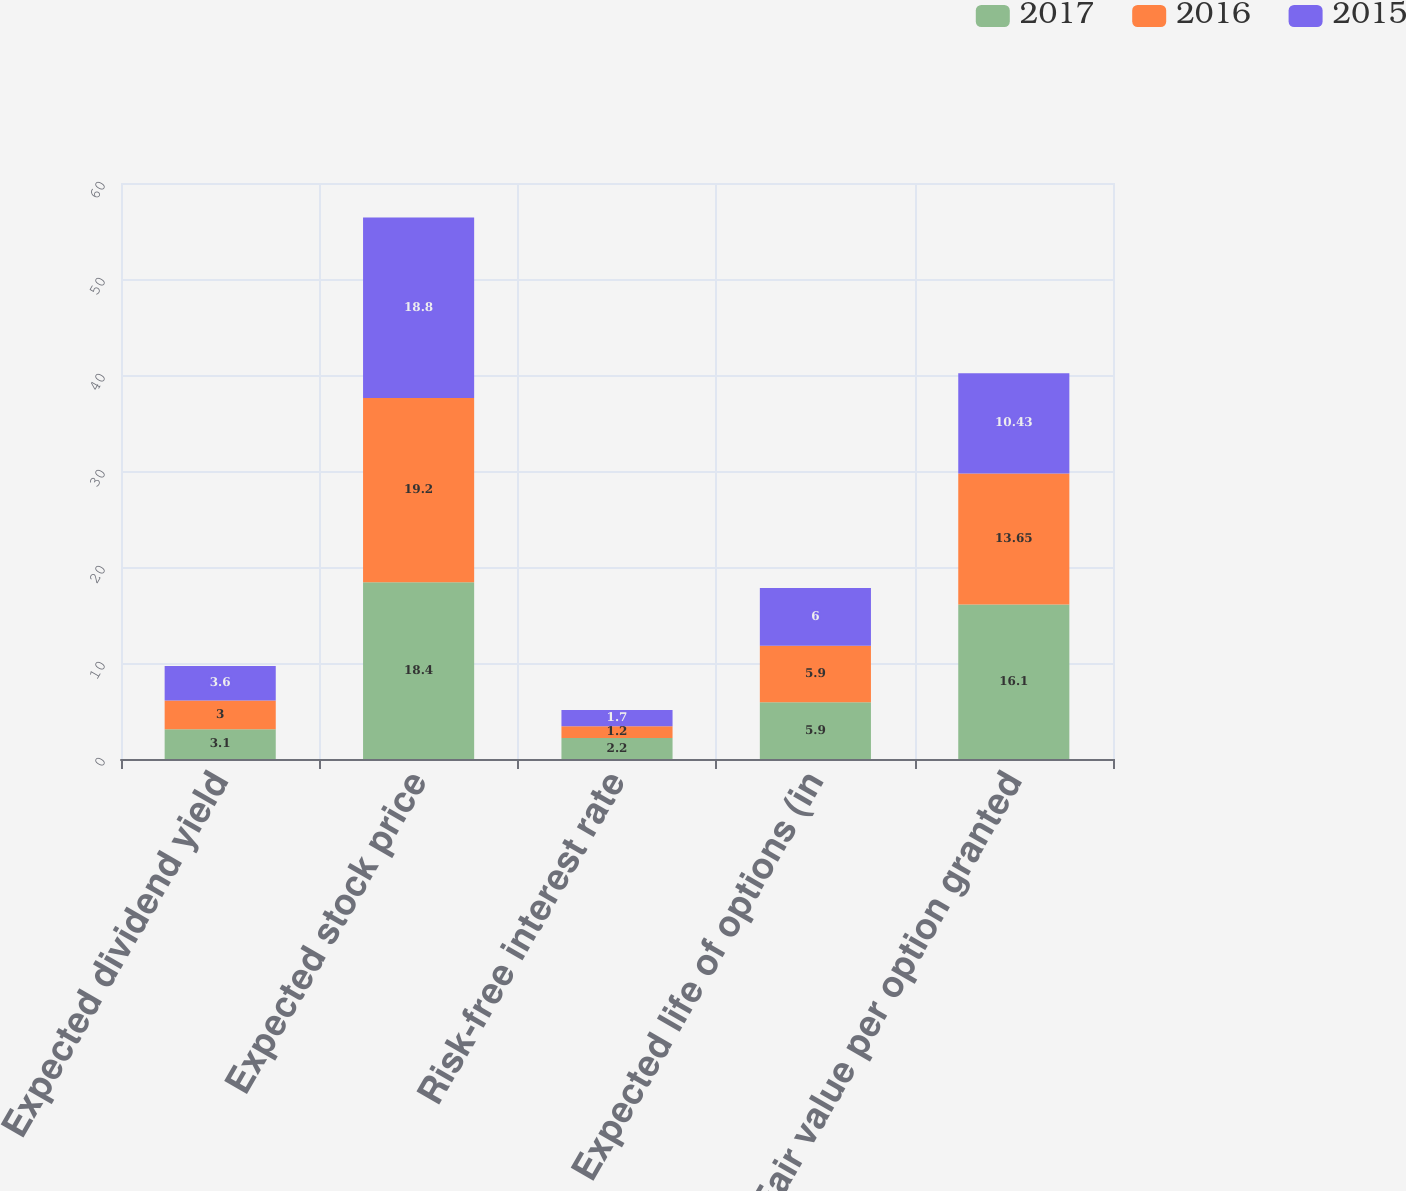Convert chart. <chart><loc_0><loc_0><loc_500><loc_500><stacked_bar_chart><ecel><fcel>Expected dividend yield<fcel>Expected stock price<fcel>Risk-free interest rate<fcel>Expected life of options (in<fcel>Fair value per option granted<nl><fcel>2017<fcel>3.1<fcel>18.4<fcel>2.2<fcel>5.9<fcel>16.1<nl><fcel>2016<fcel>3<fcel>19.2<fcel>1.2<fcel>5.9<fcel>13.65<nl><fcel>2015<fcel>3.6<fcel>18.8<fcel>1.7<fcel>6<fcel>10.43<nl></chart> 